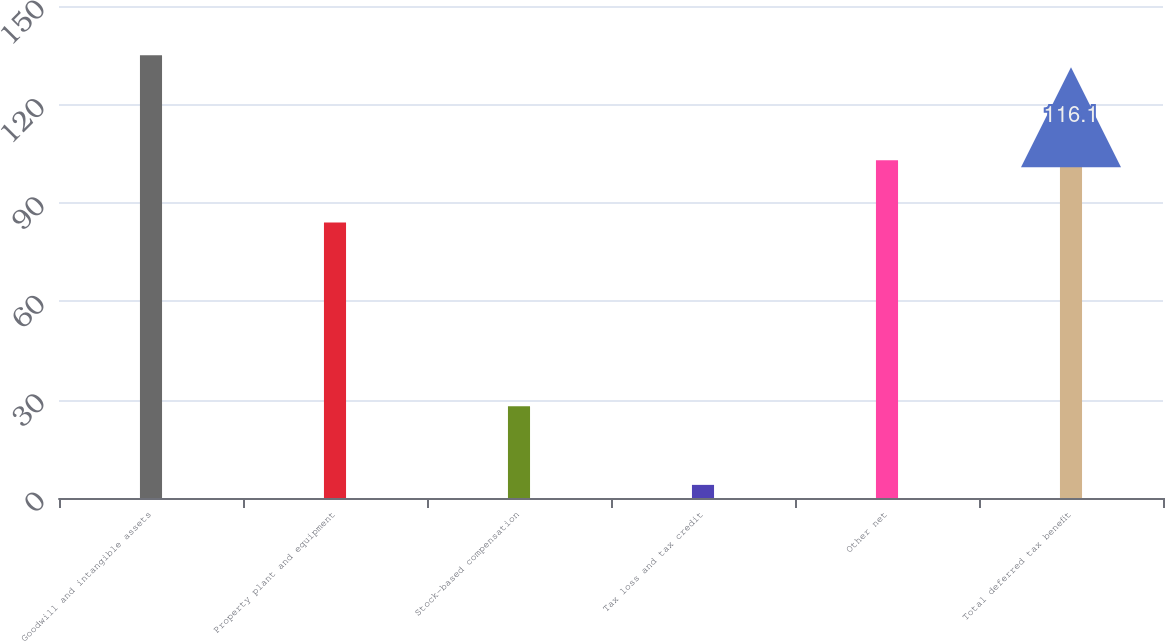<chart> <loc_0><loc_0><loc_500><loc_500><bar_chart><fcel>Goodwill and intangible assets<fcel>Property plant and equipment<fcel>Stock-based compensation<fcel>Tax loss and tax credit<fcel>Other net<fcel>Total deferred tax benefit<nl><fcel>135<fcel>84<fcel>28<fcel>4<fcel>103<fcel>116.1<nl></chart> 